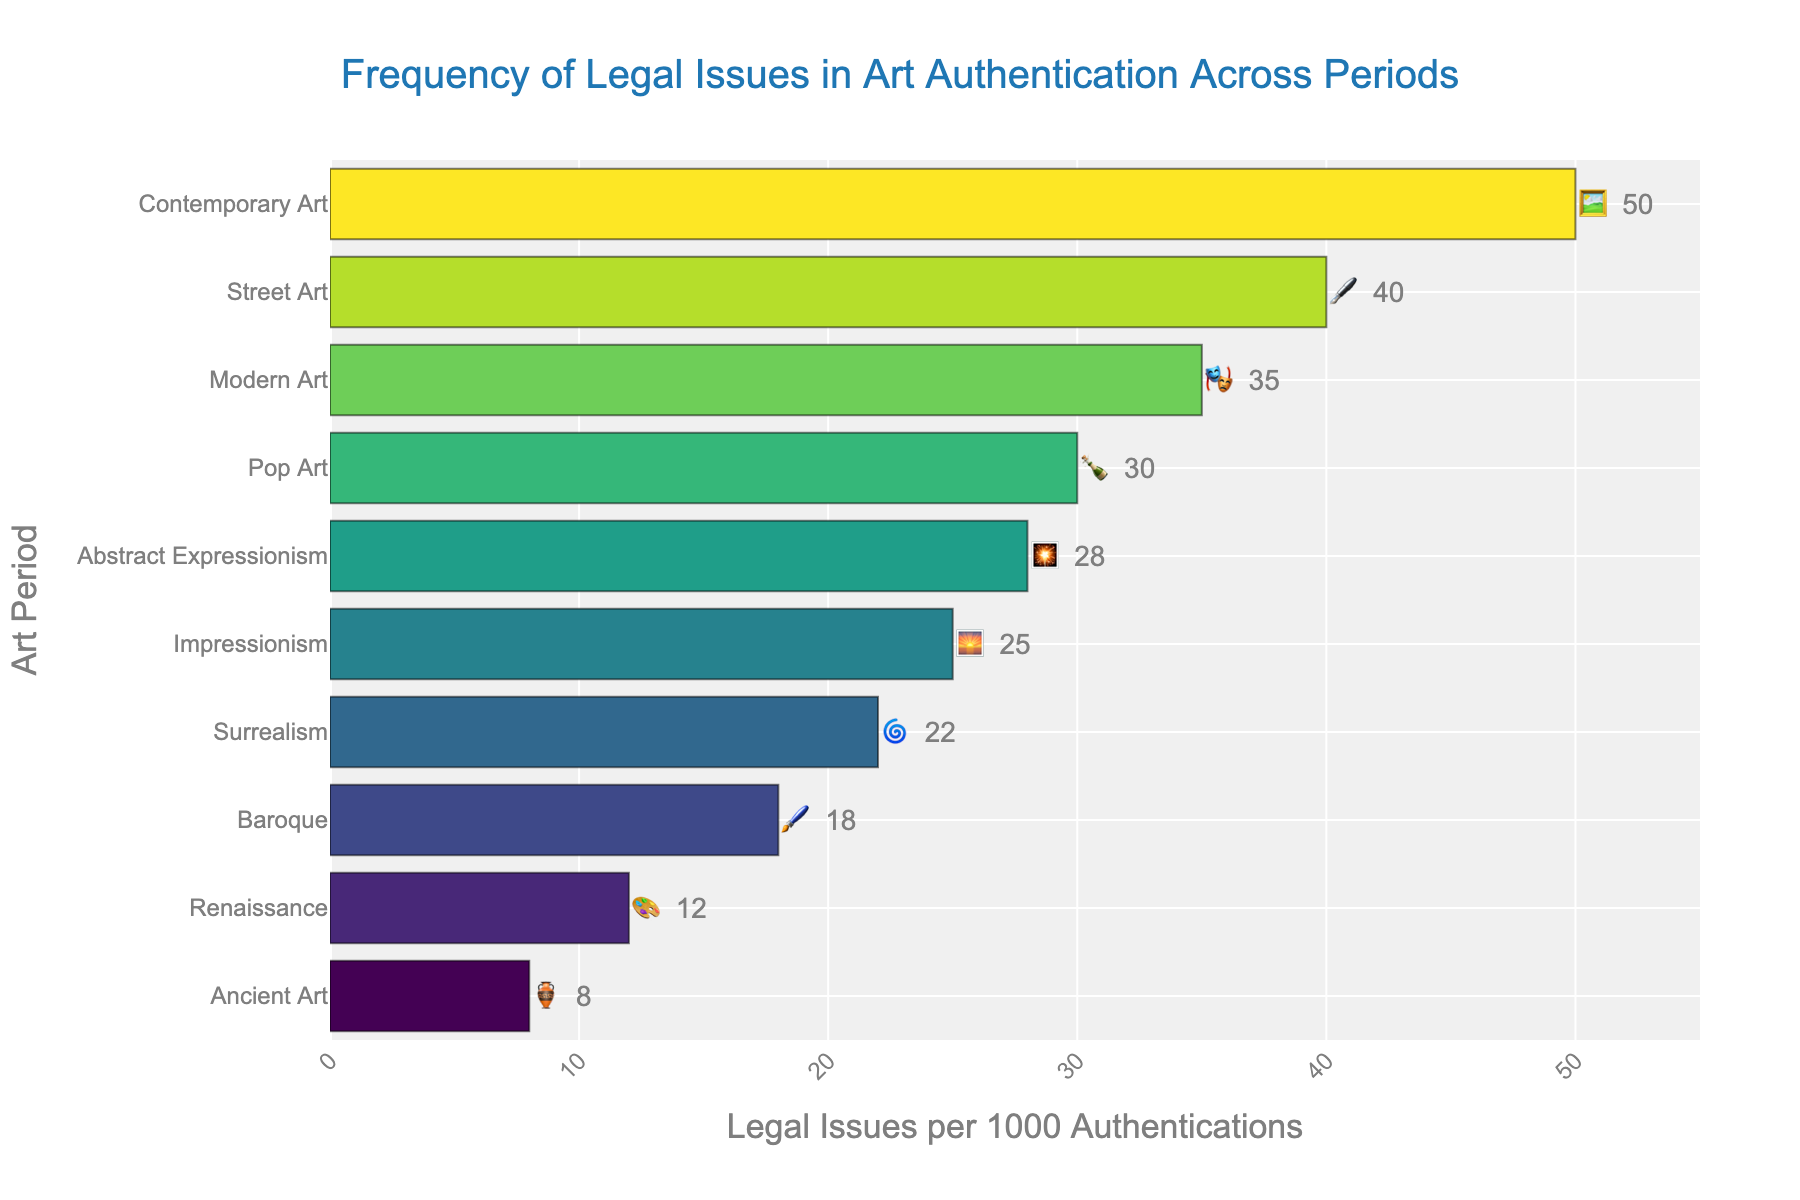What's the title of the chart? The title is displayed at the top of the chart.
Answer: Frequency of Legal Issues in Art Authentication Across Periods Which art period has the highest frequency of legal issues in art authentication per 1000 authentications? By observing the bar lengths, Contemporary Art has the longest bar, indicating the highest frequency.
Answer: Contemporary Art How many legal issues per 1000 authentications are associated with Renaissance art? The bar for Renaissance art shows a value of 12.
Answer: 12 Which two art periods have the closest frequencies of legal issues, and what are their values? Abstract Expressionism and Pop Art have close bar lengths, indicating values of 28 and 30 respectively.
Answer: Abstract Expressionism (28), Pop Art (30) What is the range of legal issues per 1000 authentications across all periods? The minimum value is 8 (Ancient Art) and the maximum is 50 (Contemporary Art), so the range is 50 - 8 = 42.
Answer: 42 Compare the frequency of legal issues in Impressionism and Surrealism. Which one is higher and by how much? Impressionism has a value of 25 and Surrealism has 22, so Impressionism is higher by 25 - 22 = 3.
Answer: Impressionism by 3 What is the average frequency of legal issues per 1000 authentications for all art periods shown? Sum all values (12 + 18 + 25 + 35 + 50 + 8 + 30 + 28 + 22 + 40 = 268) and divide by the number of periods (10).
Answer: 26.8 What is the order of art periods from the lowest to the highest frequency of legal issues? By observing the sorted bar lengths from smallest to largest: Ancient Art, Renaissance, Baroque, Impressionism, Surrealism, Abstract Expressionism, Pop Art, Modern Art, Street Art, Contemporary Art.
Answer: Ancient Art, Renaissance, Baroque, Impressionism, Surrealism, Abstract Expressionism, Pop Art, Modern Art, Street Art, Contemporary Art Which art periods have a higher frequency of legal issues than Baroque art? Baroque has 18 legal issues per 1000 authentications; periods with higher values are Impressionism, Modern Art, Contemporary Art, Pop Art, Abstract Expressionism, Surrealism, and Street Art.
Answer: Impressionism, Modern Art, Contemporary Art, Pop Art, Abstract Expressionism, Surrealism, Street Art 